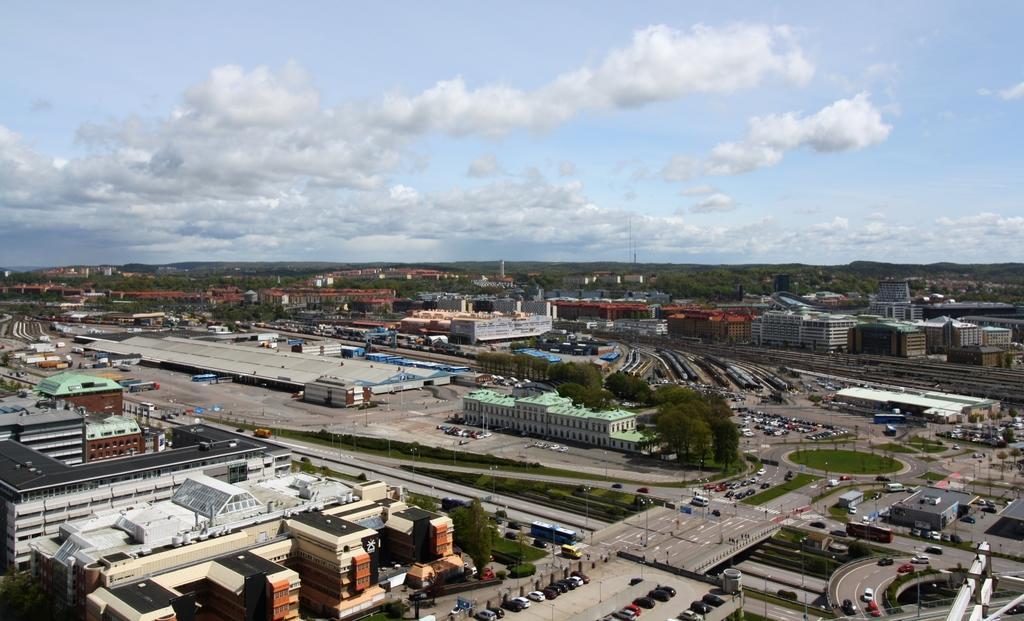How would you summarize this image in a sentence or two? In this image we can see a group of buildings with windows and roofs. In the center of the image we can see a group of trees. In the foreground we can see group of vehicles parked on the road. In the background, we can see mountains and the cloudy sky. 